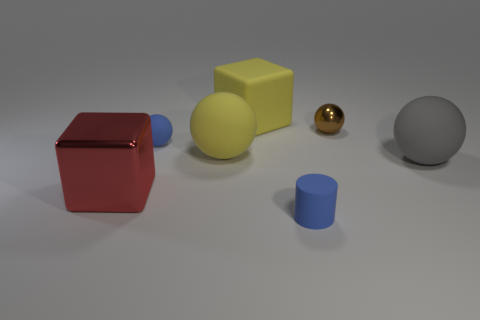Is the material of the yellow sphere the same as the small thing to the right of the small rubber cylinder?
Your answer should be very brief. No. There is a small thing that is the same color as the matte cylinder; what is it made of?
Offer a terse response. Rubber. Are there fewer balls than things?
Your response must be concise. Yes. There is a block behind the yellow rubber ball; does it have the same size as the blue thing that is behind the gray matte thing?
Give a very brief answer. No. How many green objects are small things or large things?
Provide a succinct answer. 0. What size is the ball that is the same color as the small rubber cylinder?
Provide a short and direct response. Small. Is the number of tiny blue balls greater than the number of tiny spheres?
Give a very brief answer. No. Is the color of the tiny rubber cylinder the same as the tiny rubber sphere?
Offer a terse response. Yes. What number of objects are either green spheres or blue things to the left of the cylinder?
Your answer should be compact. 1. What number of other things are the same shape as the brown thing?
Make the answer very short. 3. 